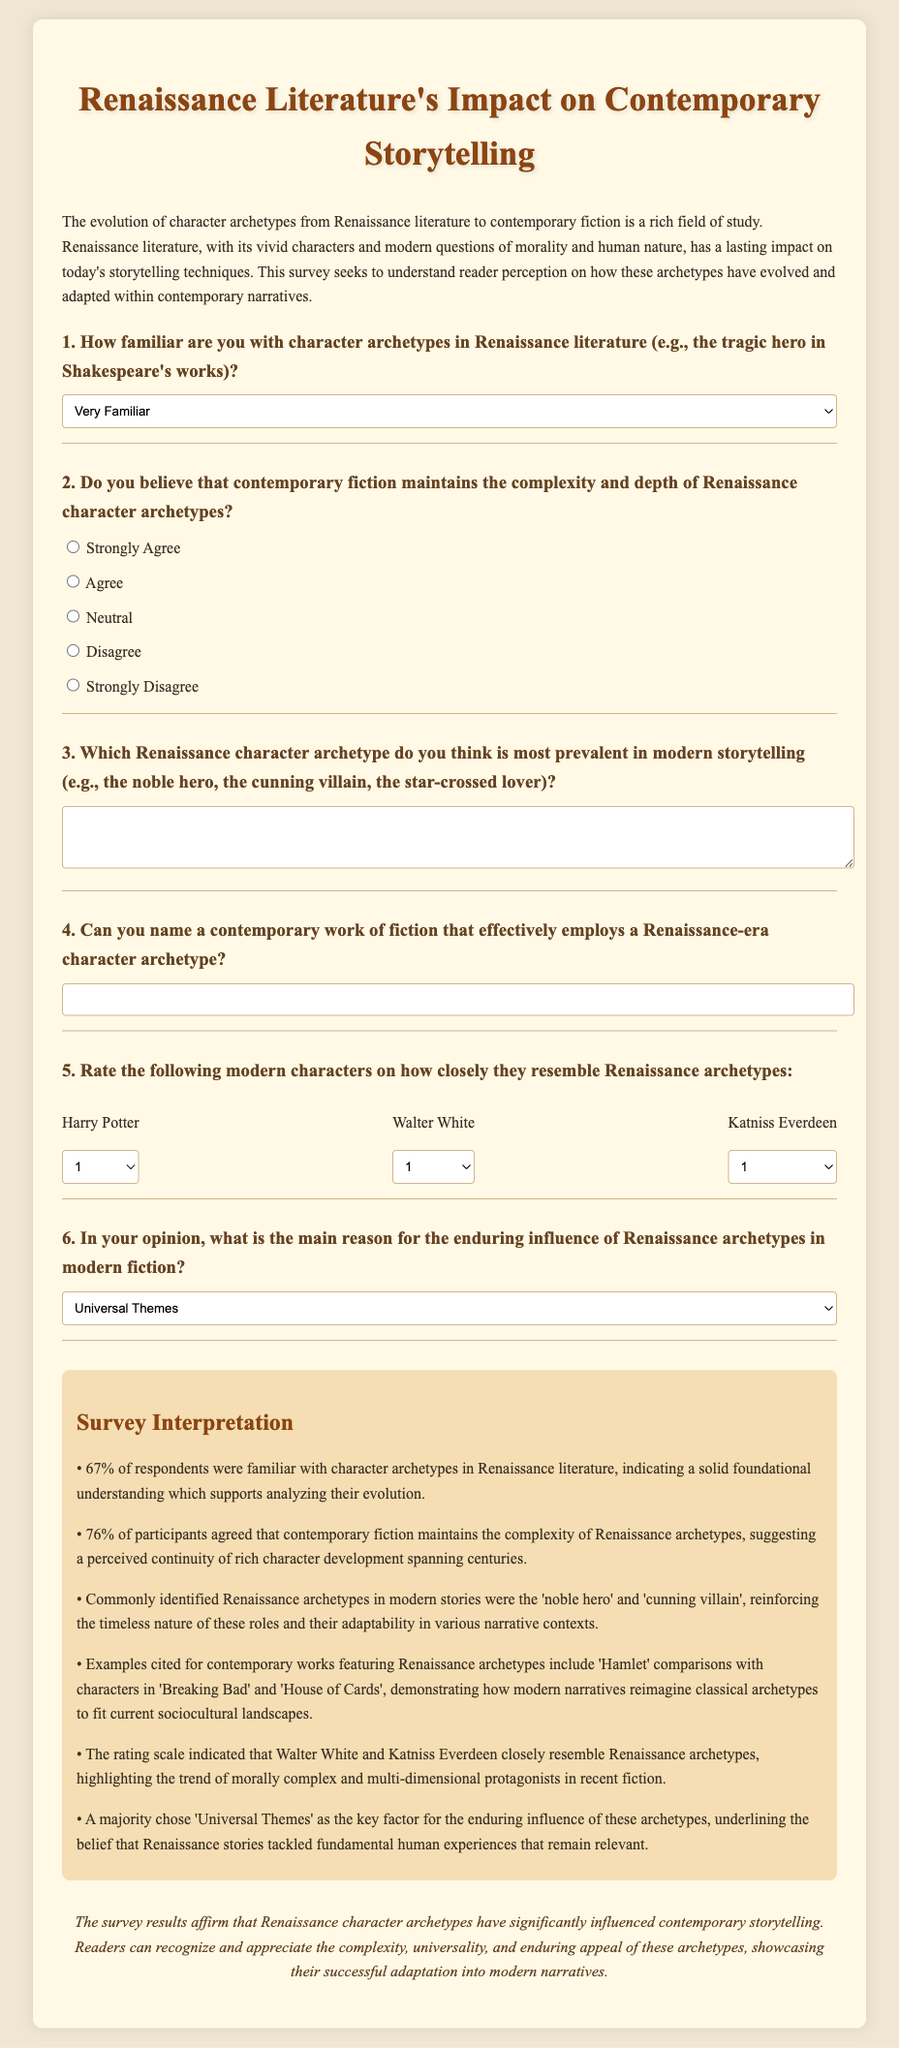How many respondents were familiar with character archetypes in Renaissance literature? The document states that 67% of respondents were familiar with character archetypes in Renaissance literature.
Answer: 67% What percentage of participants agreed that contemporary fiction maintains the complexity of Renaissance archetypes? The document mentions that 76% of participants agreed on this point.
Answer: 76% Which character was commonly compared to Hamlet in contemporary works? The document cites Walter White from 'Breaking Bad' as a character commonly compared to Hamlet.
Answer: Walter White What is the main reason for the enduring influence of Renaissance archetypes in modern fiction according to the majority? The document indicates that the majority chose 'Universal Themes' as the reason for this influence.
Answer: Universal Themes Name a modern character rated for resembling Renaissance archetypes. The document discusses characters such as Harry Potter, Walter White, and Katniss Everdeen being rated on this resemblance.
Answer: Katniss Everdeen 